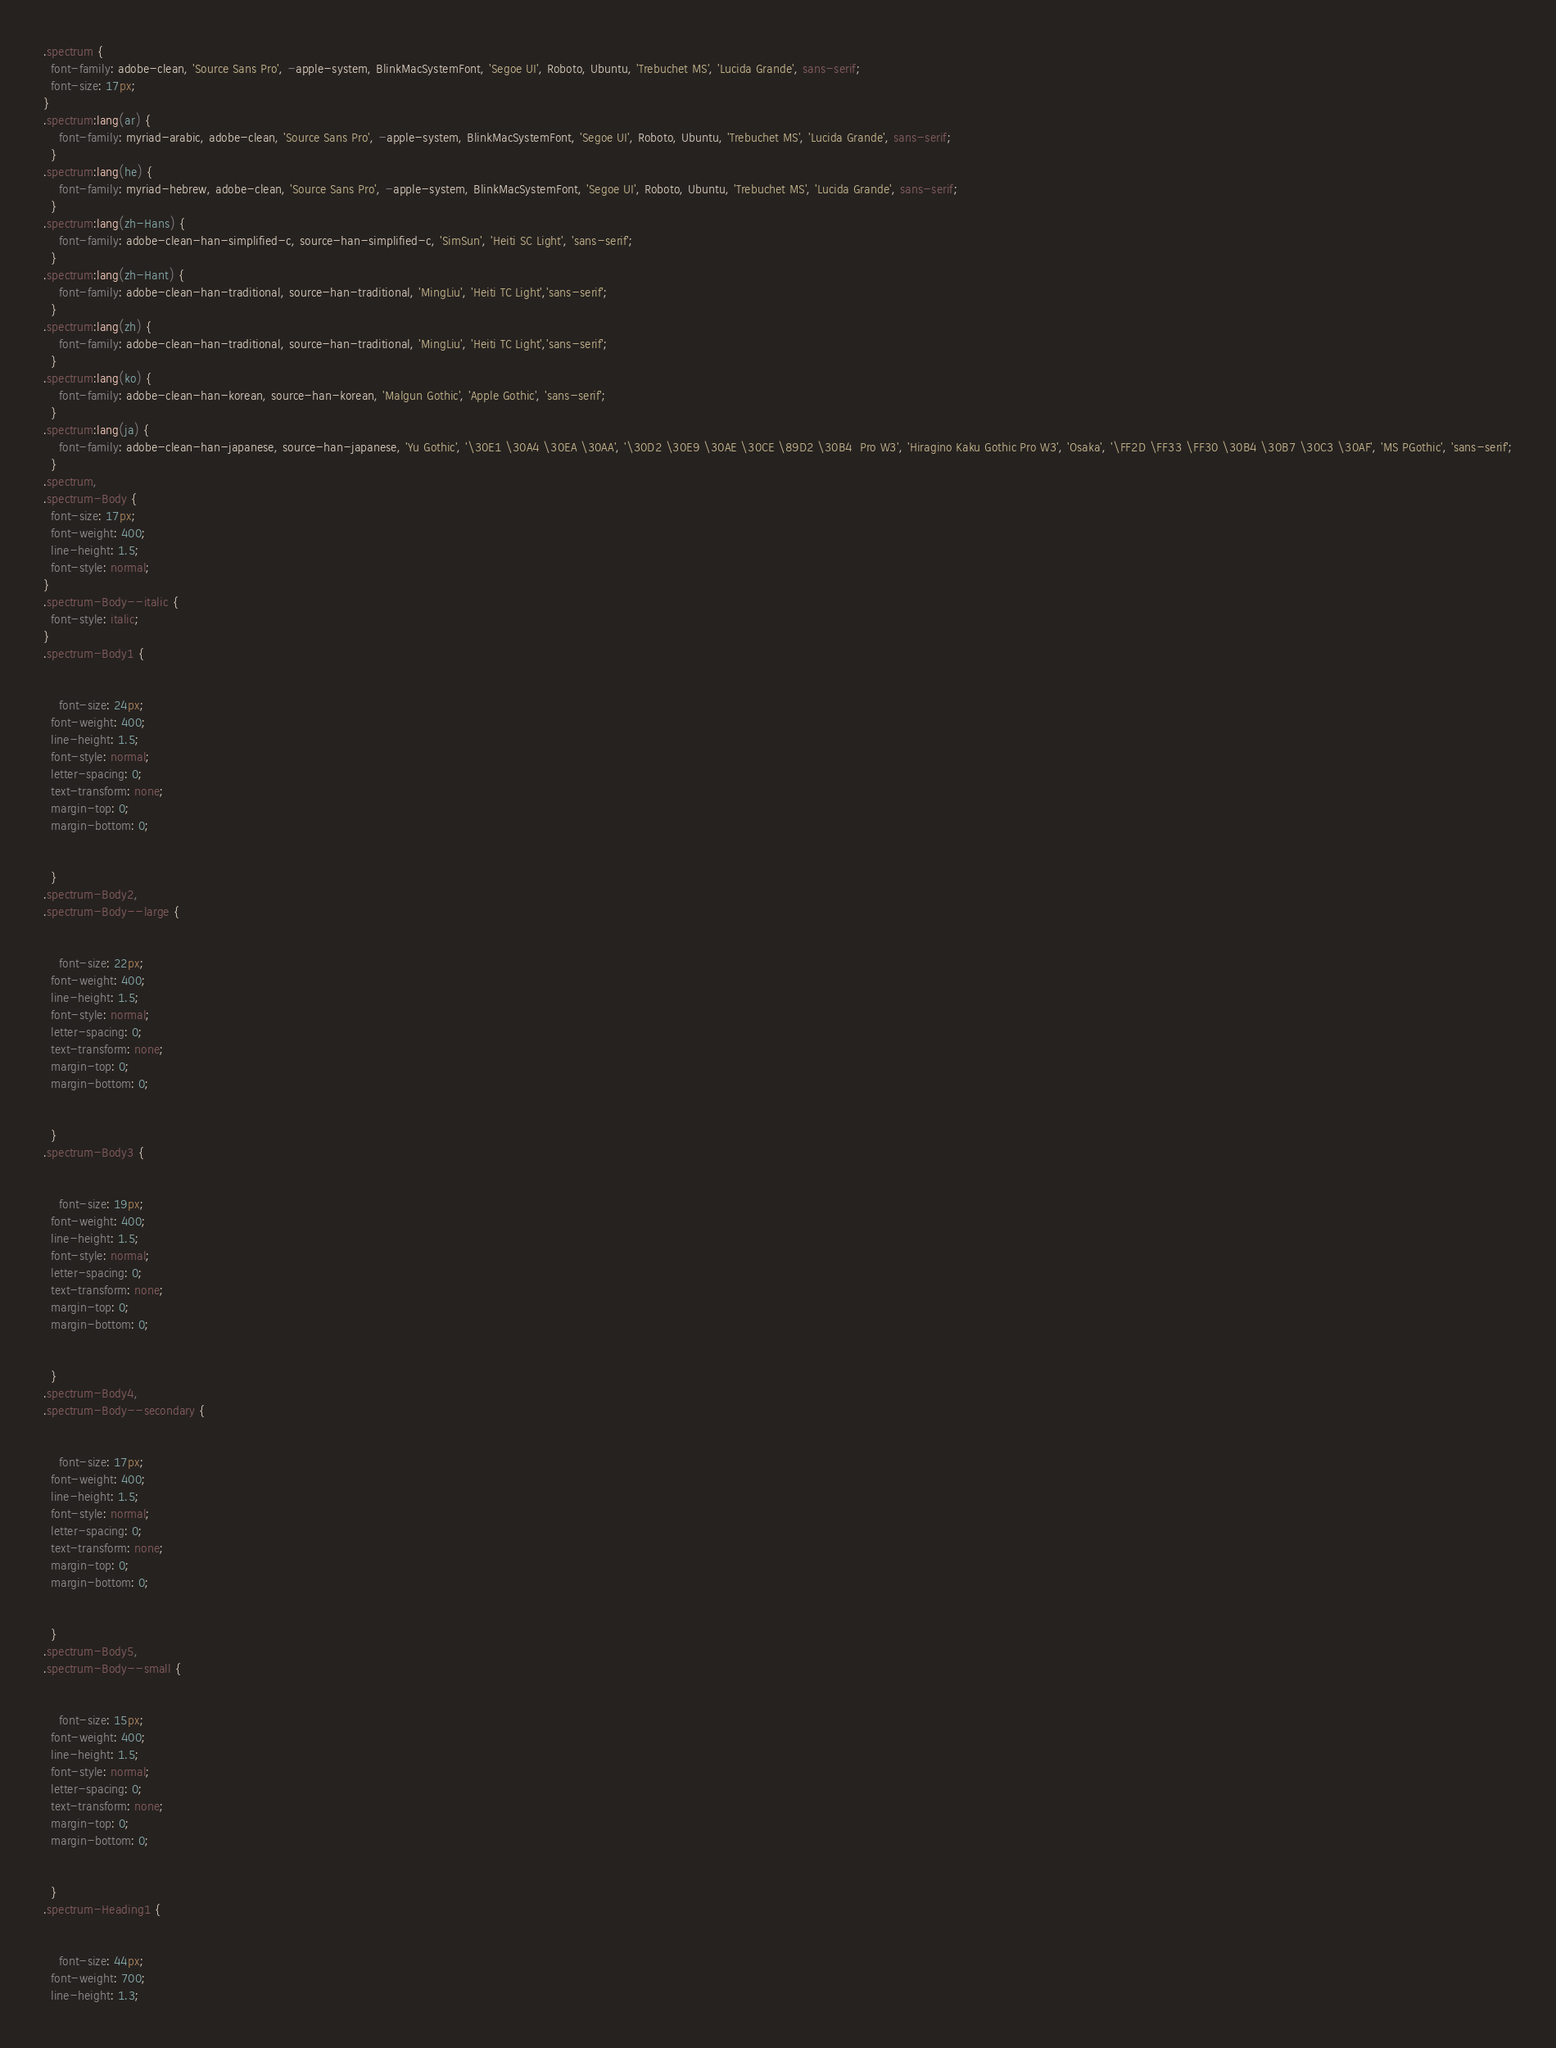Convert code to text. <code><loc_0><loc_0><loc_500><loc_500><_CSS_>.spectrum {
  font-family: adobe-clean, 'Source Sans Pro', -apple-system, BlinkMacSystemFont, 'Segoe UI', Roboto, Ubuntu, 'Trebuchet MS', 'Lucida Grande', sans-serif;
  font-size: 17px;
}
.spectrum:lang(ar) {
    font-family: myriad-arabic, adobe-clean, 'Source Sans Pro', -apple-system, BlinkMacSystemFont, 'Segoe UI', Roboto, Ubuntu, 'Trebuchet MS', 'Lucida Grande', sans-serif;
  }
.spectrum:lang(he) {
    font-family: myriad-hebrew, adobe-clean, 'Source Sans Pro', -apple-system, BlinkMacSystemFont, 'Segoe UI', Roboto, Ubuntu, 'Trebuchet MS', 'Lucida Grande', sans-serif;
  }
.spectrum:lang(zh-Hans) {
    font-family: adobe-clean-han-simplified-c, source-han-simplified-c, 'SimSun', 'Heiti SC Light', 'sans-serif';
  }
.spectrum:lang(zh-Hant) {
    font-family: adobe-clean-han-traditional, source-han-traditional, 'MingLiu', 'Heiti TC Light','sans-serif';
  }
.spectrum:lang(zh) {
    font-family: adobe-clean-han-traditional, source-han-traditional, 'MingLiu', 'Heiti TC Light','sans-serif';
  }
.spectrum:lang(ko) {
    font-family: adobe-clean-han-korean, source-han-korean, 'Malgun Gothic', 'Apple Gothic', 'sans-serif';
  }
.spectrum:lang(ja) {
    font-family: adobe-clean-han-japanese, source-han-japanese, 'Yu Gothic', '\30E1 \30A4 \30EA \30AA', '\30D2 \30E9 \30AE \30CE \89D2 \30B4  Pro W3', 'Hiragino Kaku Gothic Pro W3', 'Osaka', '\FF2D \FF33 \FF30 \30B4 \30B7 \30C3 \30AF', 'MS PGothic', 'sans-serif';
  }
.spectrum,
.spectrum-Body {
  font-size: 17px;
  font-weight: 400;
  line-height: 1.5;
  font-style: normal;
}
.spectrum-Body--italic {
  font-style: italic;
}
.spectrum-Body1 {
  

    font-size: 24px;
  font-weight: 400;
  line-height: 1.5;
  font-style: normal;
  letter-spacing: 0;
  text-transform: none;
  margin-top: 0;
  margin-bottom: 0;

    
  }
.spectrum-Body2,
.spectrum-Body--large {
  

    font-size: 22px;
  font-weight: 400;
  line-height: 1.5;
  font-style: normal;
  letter-spacing: 0;
  text-transform: none;
  margin-top: 0;
  margin-bottom: 0;

    
  }
.spectrum-Body3 {
  

    font-size: 19px;
  font-weight: 400;
  line-height: 1.5;
  font-style: normal;
  letter-spacing: 0;
  text-transform: none;
  margin-top: 0;
  margin-bottom: 0;

    
  }
.spectrum-Body4,
.spectrum-Body--secondary {
  

    font-size: 17px;
  font-weight: 400;
  line-height: 1.5;
  font-style: normal;
  letter-spacing: 0;
  text-transform: none;
  margin-top: 0;
  margin-bottom: 0;

    
  }
.spectrum-Body5,
.spectrum-Body--small {
  

    font-size: 15px;
  font-weight: 400;
  line-height: 1.5;
  font-style: normal;
  letter-spacing: 0;
  text-transform: none;
  margin-top: 0;
  margin-bottom: 0;

    
  }
.spectrum-Heading1 {
  

    font-size: 44px;
  font-weight: 700;
  line-height: 1.3;</code> 